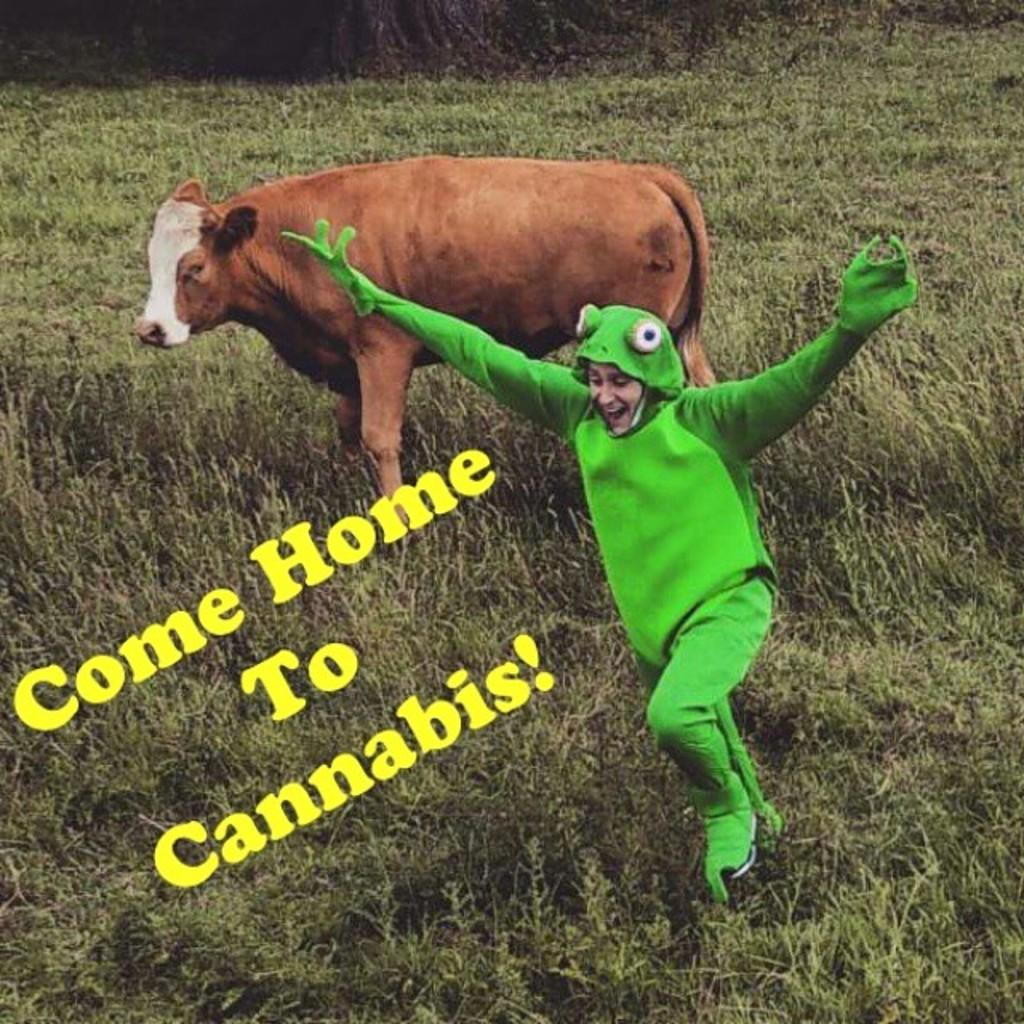What is the person in the image wearing? The person in the image is wearing a green dress. What can be seen in the background of the image? There is an animal present on the grass in the background of the image. Can you describe any text in the image? Yes, the image contains yellow-colored text. What type of jeans is the person wearing in the image? The person in the image is not wearing jeans; they are wearing a green dress. Can you describe the rod used by the person to catch fish in the image? There is no rod or fishing activity depicted in the image. 